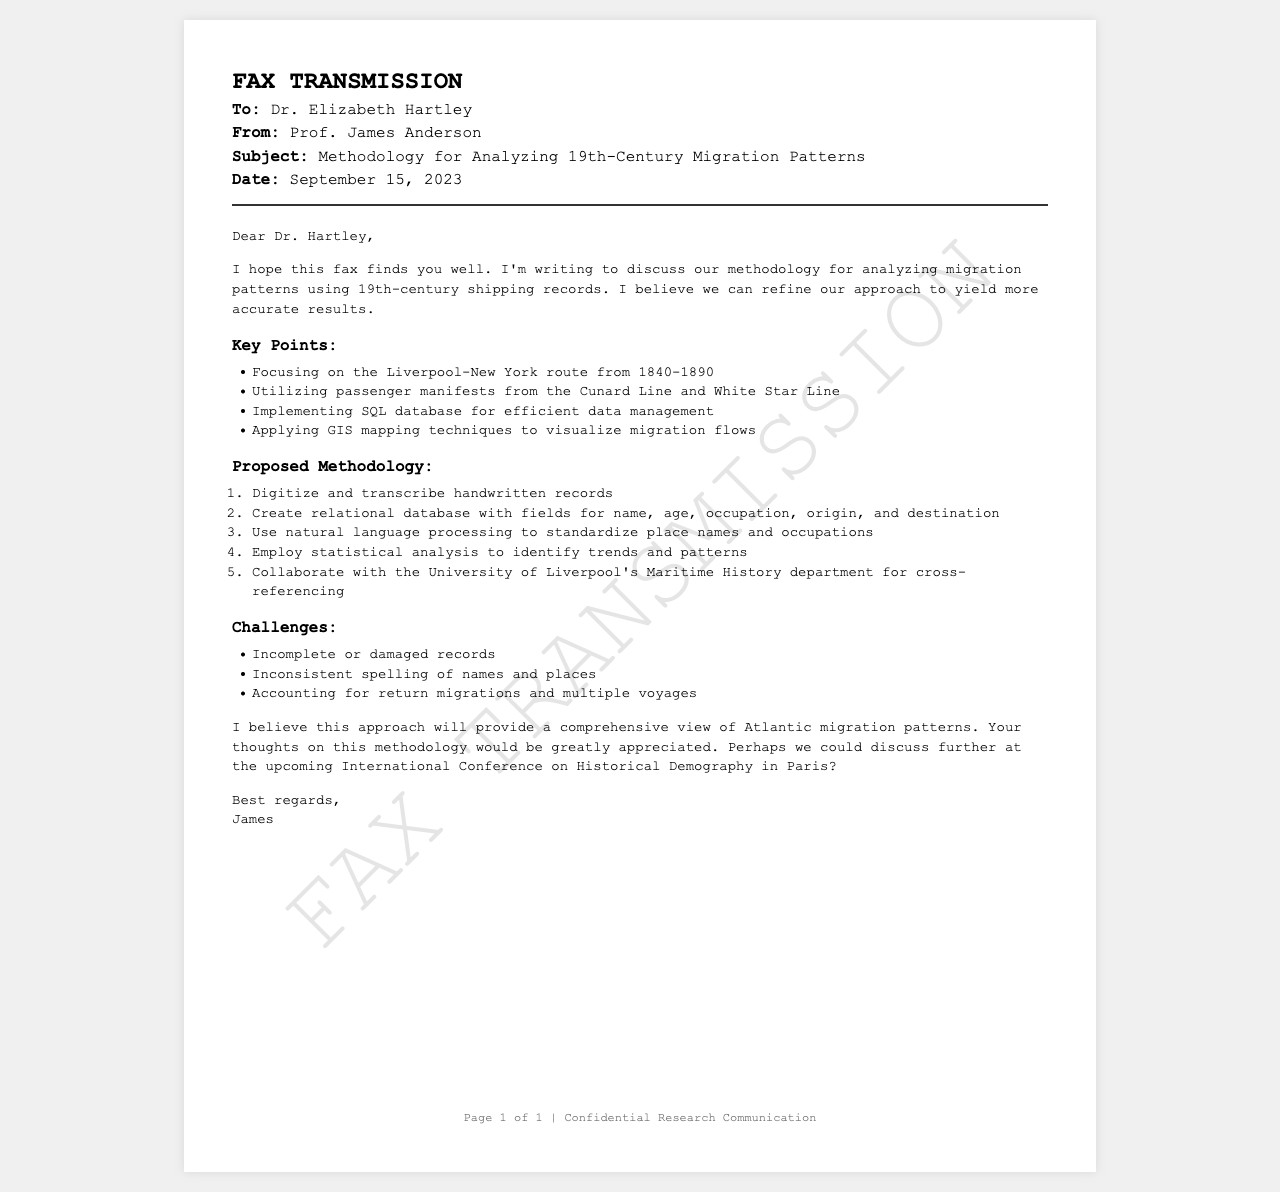What is the name of the recipient? The recipient's name is explicitly mentioned in the header of the fax as Dr. Elizabeth Hartley.
Answer: Dr. Elizabeth Hartley Who is sending the fax? The sender's name is provided in the header section of the fax and is Prof. James Anderson.
Answer: Prof. James Anderson What is the subject of the fax? The subject line in the header clearly states the purpose of the correspondence regarding the methodology for analyzing migration patterns.
Answer: Methodology for Analyzing 19th-Century Migration Patterns What route is being focused on for the analysis? The key points section cites the specific route of interest for migration patterns, which is from Liverpool to New York.
Answer: Liverpool-New York What is the time period for the study mentioned in the fax? The timeframe covered in the key points for the analysis is explicitly noted as 1840-1890.
Answer: 1840-1890 What type of database is proposed for data management? The proposed methodology section mentions the use of an SQL database for managing the data efficiently.
Answer: SQL database What is one challenge mentioned in analyzing the records? One of the challenges cited in the challenges section is that records may be incomplete or damaged.
Answer: Incomplete or damaged records How many key points are outlined in the methodology? The number of key points listed can be counted in the relevant section; there are four key points.
Answer: Four What kind of department is suggested for collaboration? The proposed methodology suggests collaboration with the Maritime History department at the University of Liverpool.
Answer: Maritime History department When is the upcoming conference mentioned for discussion? The fax mentions the forthcoming International Conference on Historical Demography taking place in Paris.
Answer: International Conference on Historical Demography in Paris 